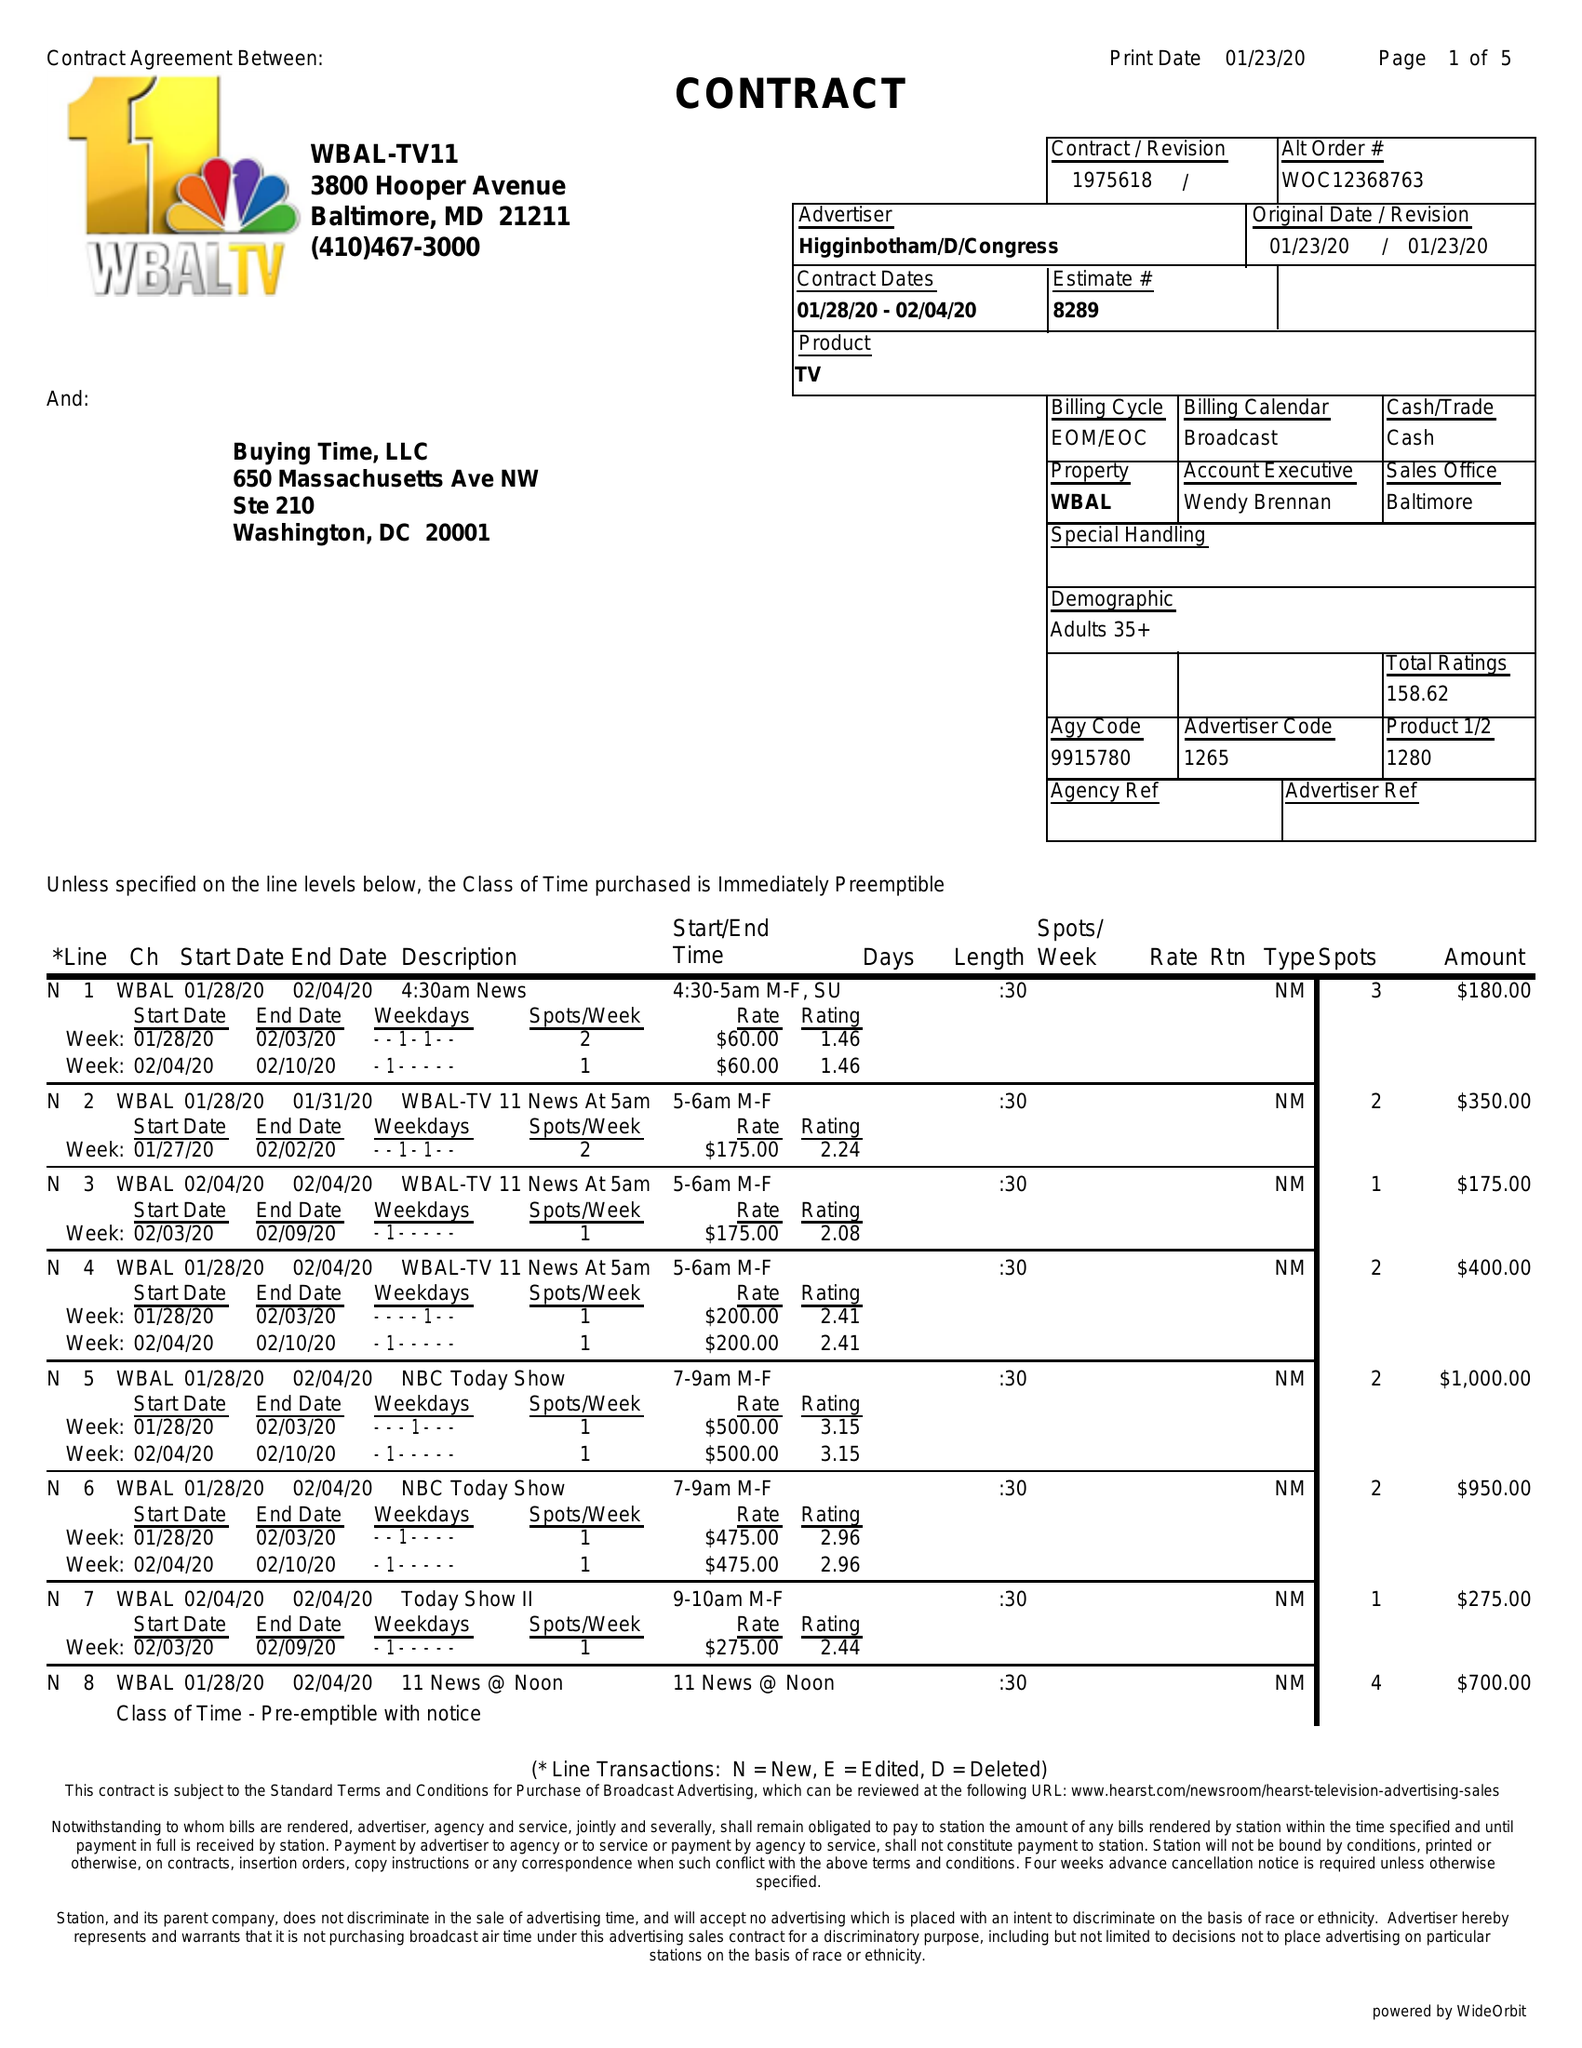What is the value for the advertiser?
Answer the question using a single word or phrase. HIGGINBOTHAM/D/CONGRESS 